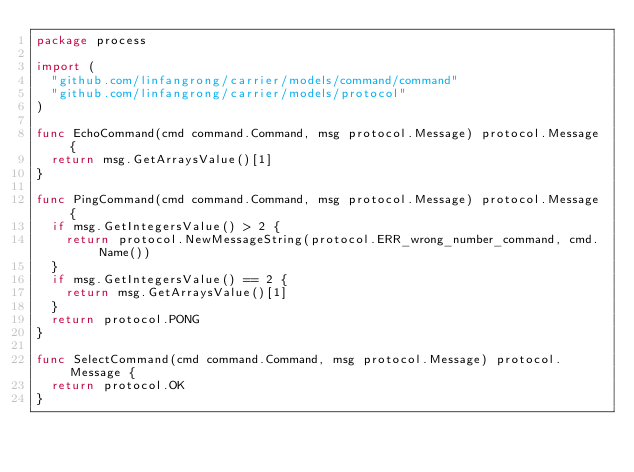<code> <loc_0><loc_0><loc_500><loc_500><_Go_>package process

import (
	"github.com/linfangrong/carrier/models/command/command"
	"github.com/linfangrong/carrier/models/protocol"
)

func EchoCommand(cmd command.Command, msg protocol.Message) protocol.Message {
	return msg.GetArraysValue()[1]
}

func PingCommand(cmd command.Command, msg protocol.Message) protocol.Message {
	if msg.GetIntegersValue() > 2 {
		return protocol.NewMessageString(protocol.ERR_wrong_number_command, cmd.Name())
	}
	if msg.GetIntegersValue() == 2 {
		return msg.GetArraysValue()[1]
	}
	return protocol.PONG
}

func SelectCommand(cmd command.Command, msg protocol.Message) protocol.Message {
	return protocol.OK
}
</code> 